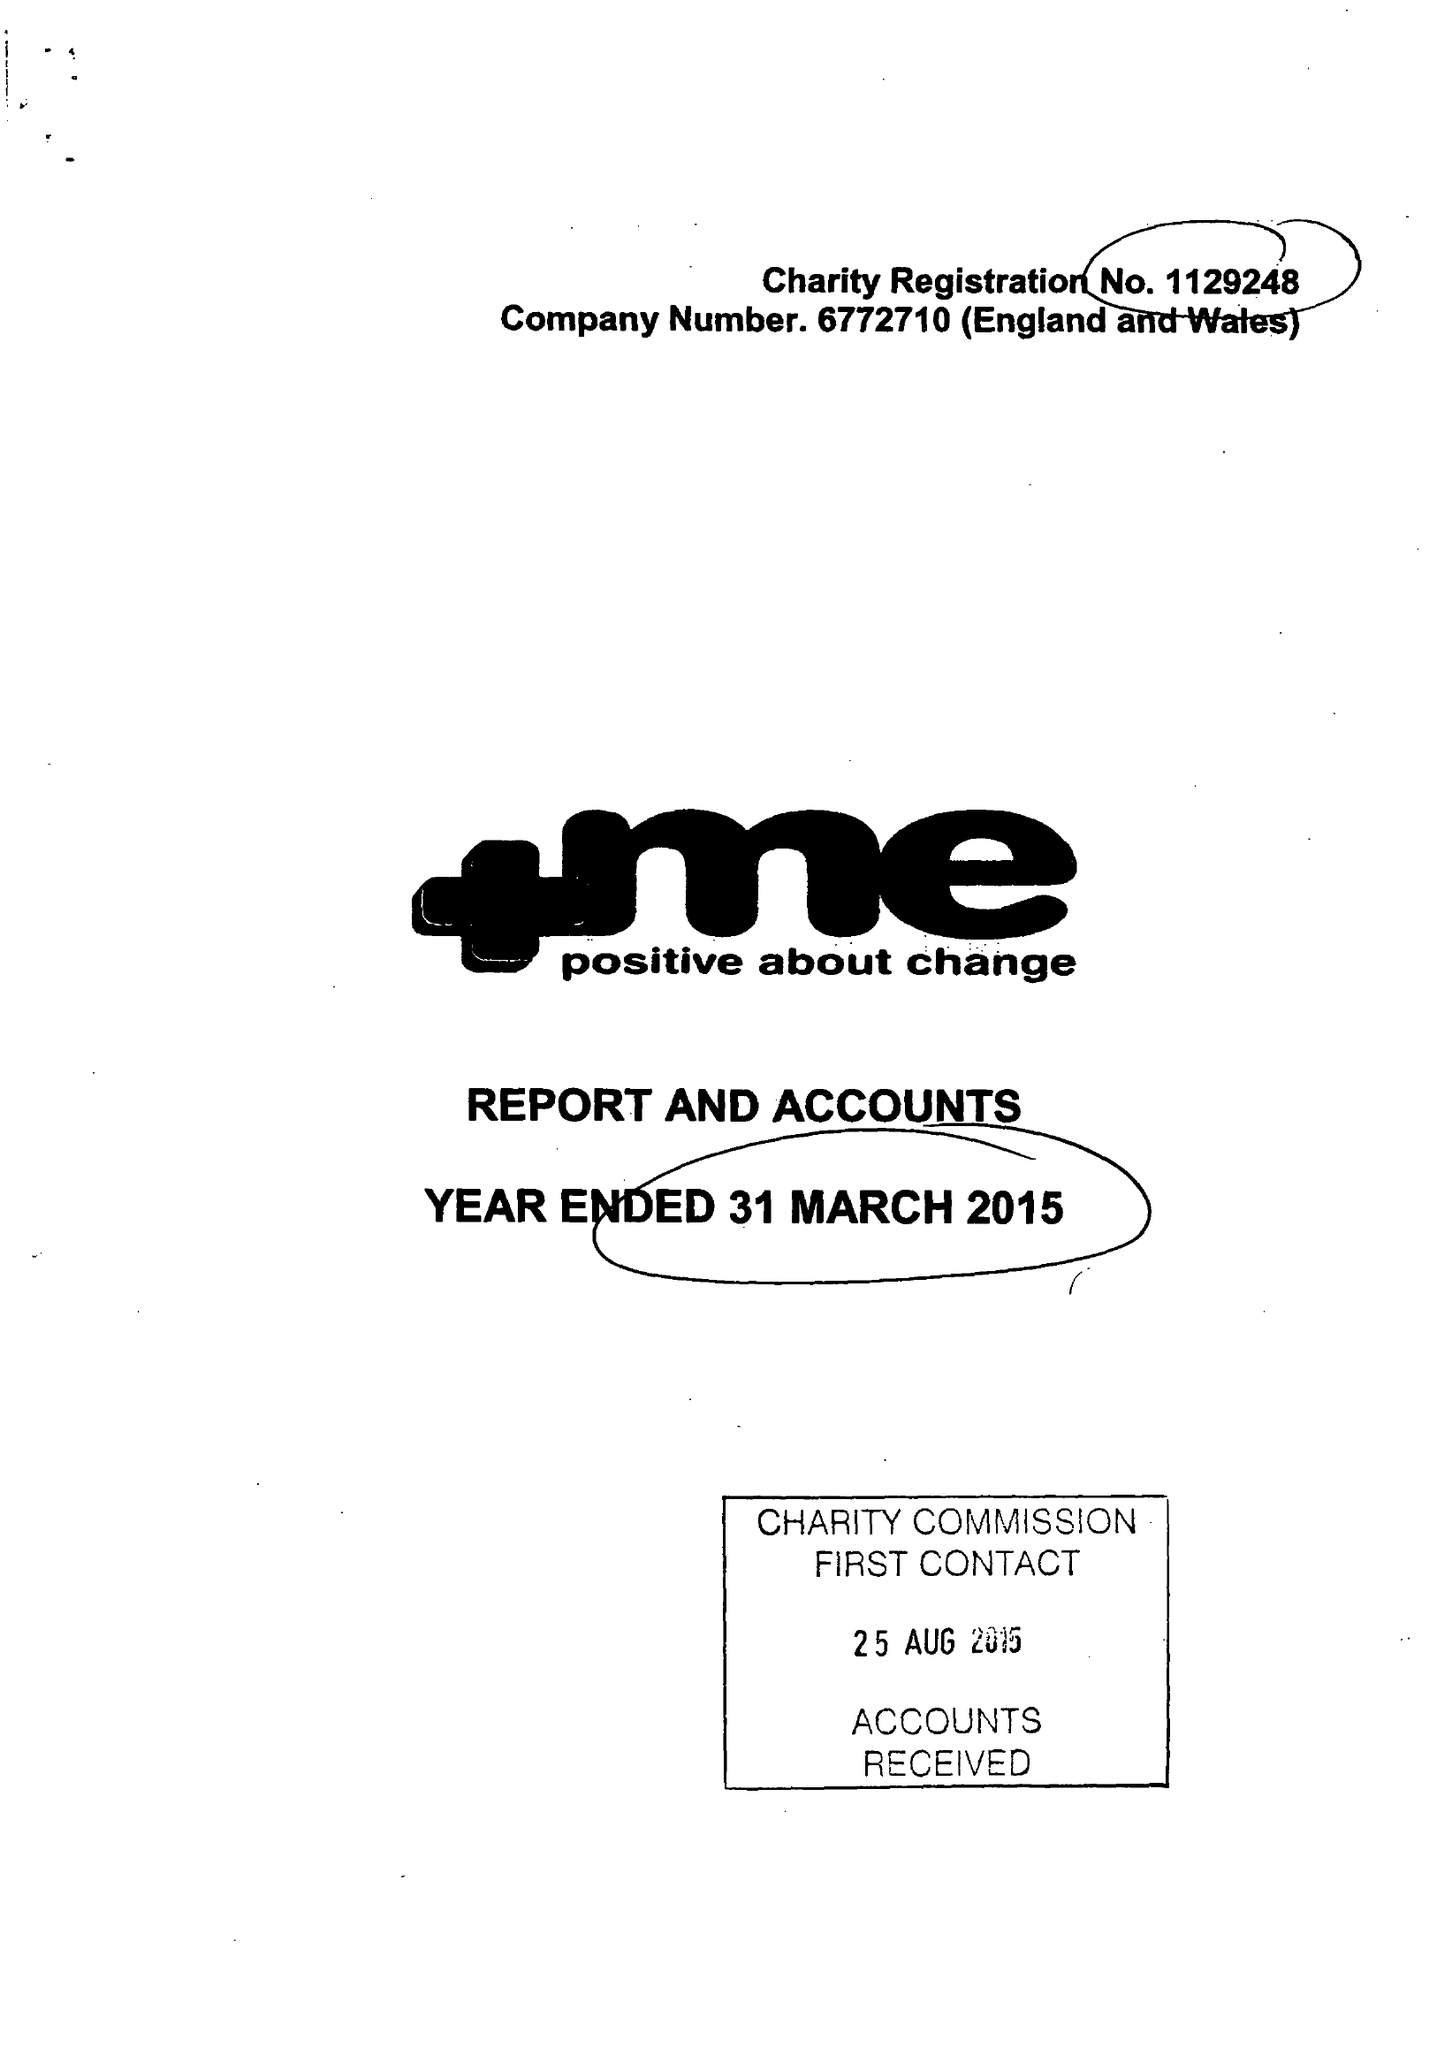What is the value for the address__street_line?
Answer the question using a single word or phrase. 23 QUEENS ROAD 